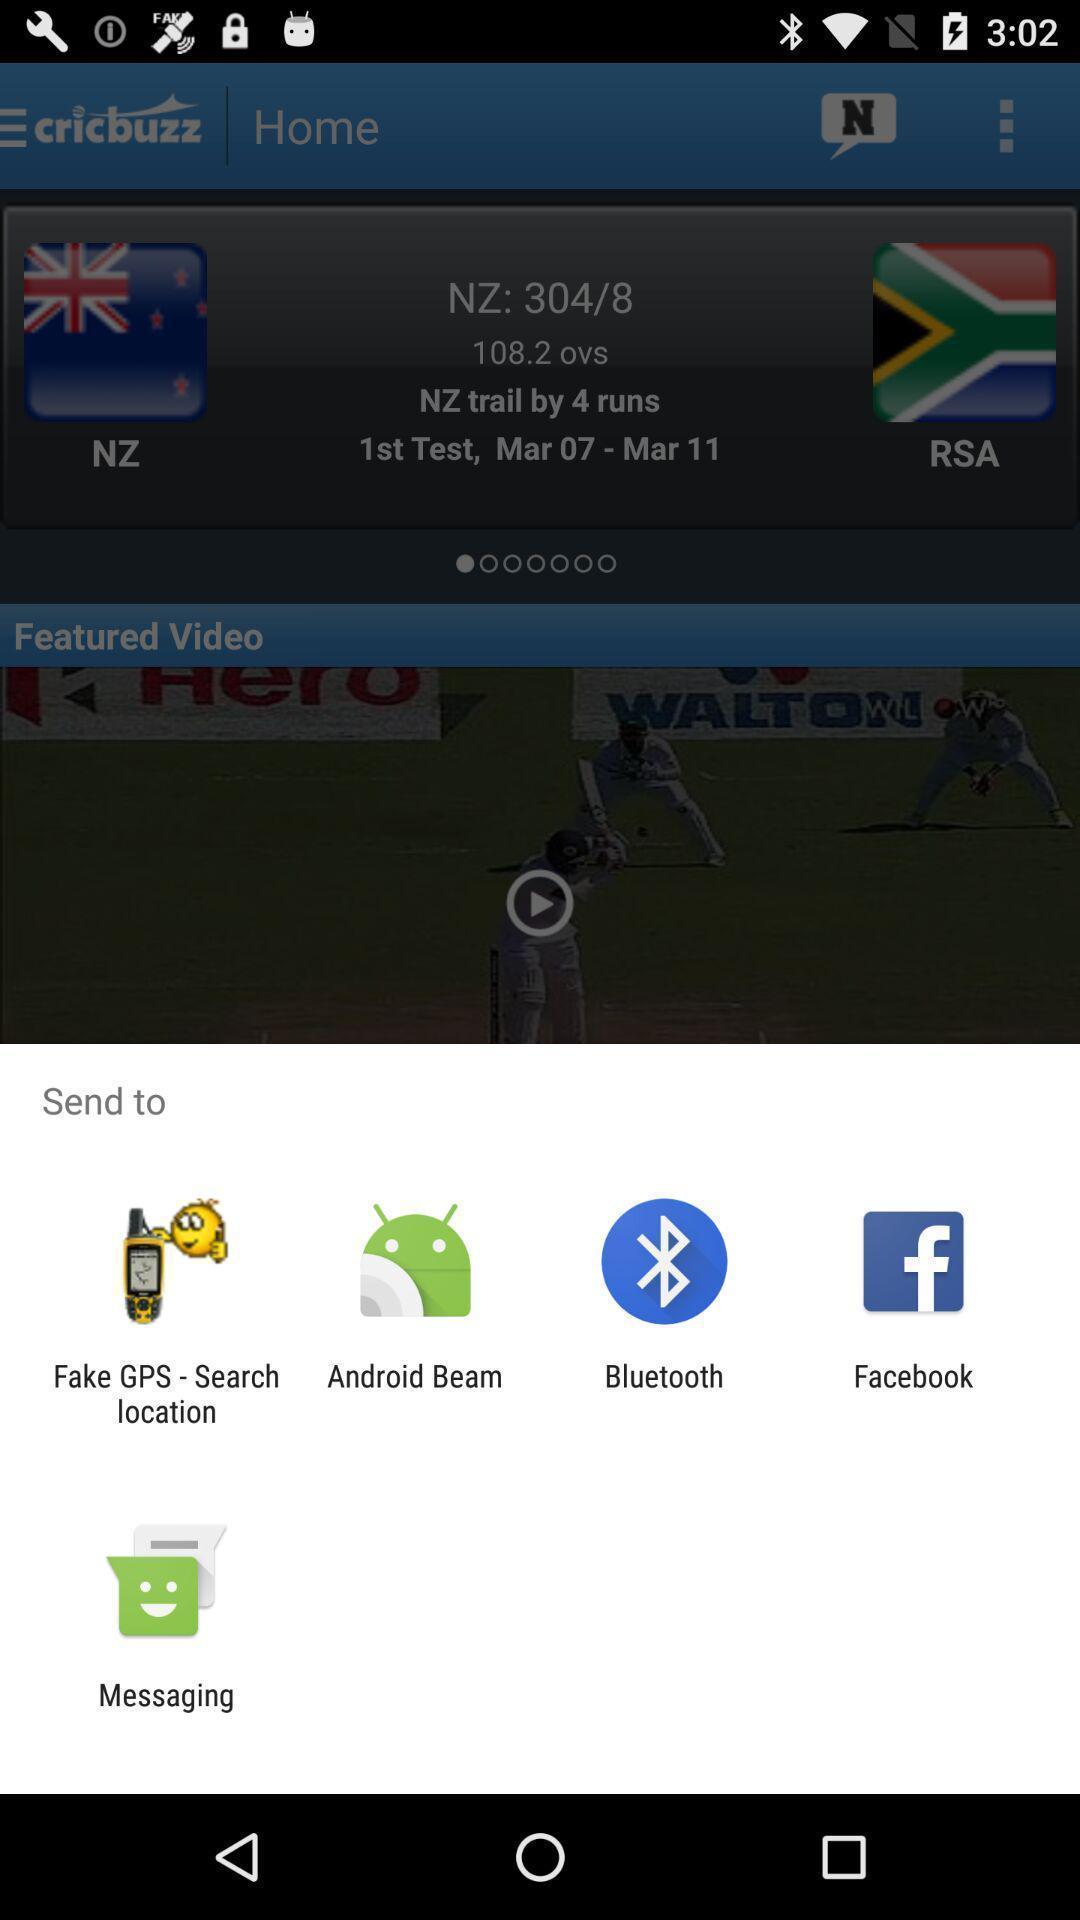Provide a description of this screenshot. Popup of different apps to share the information. 